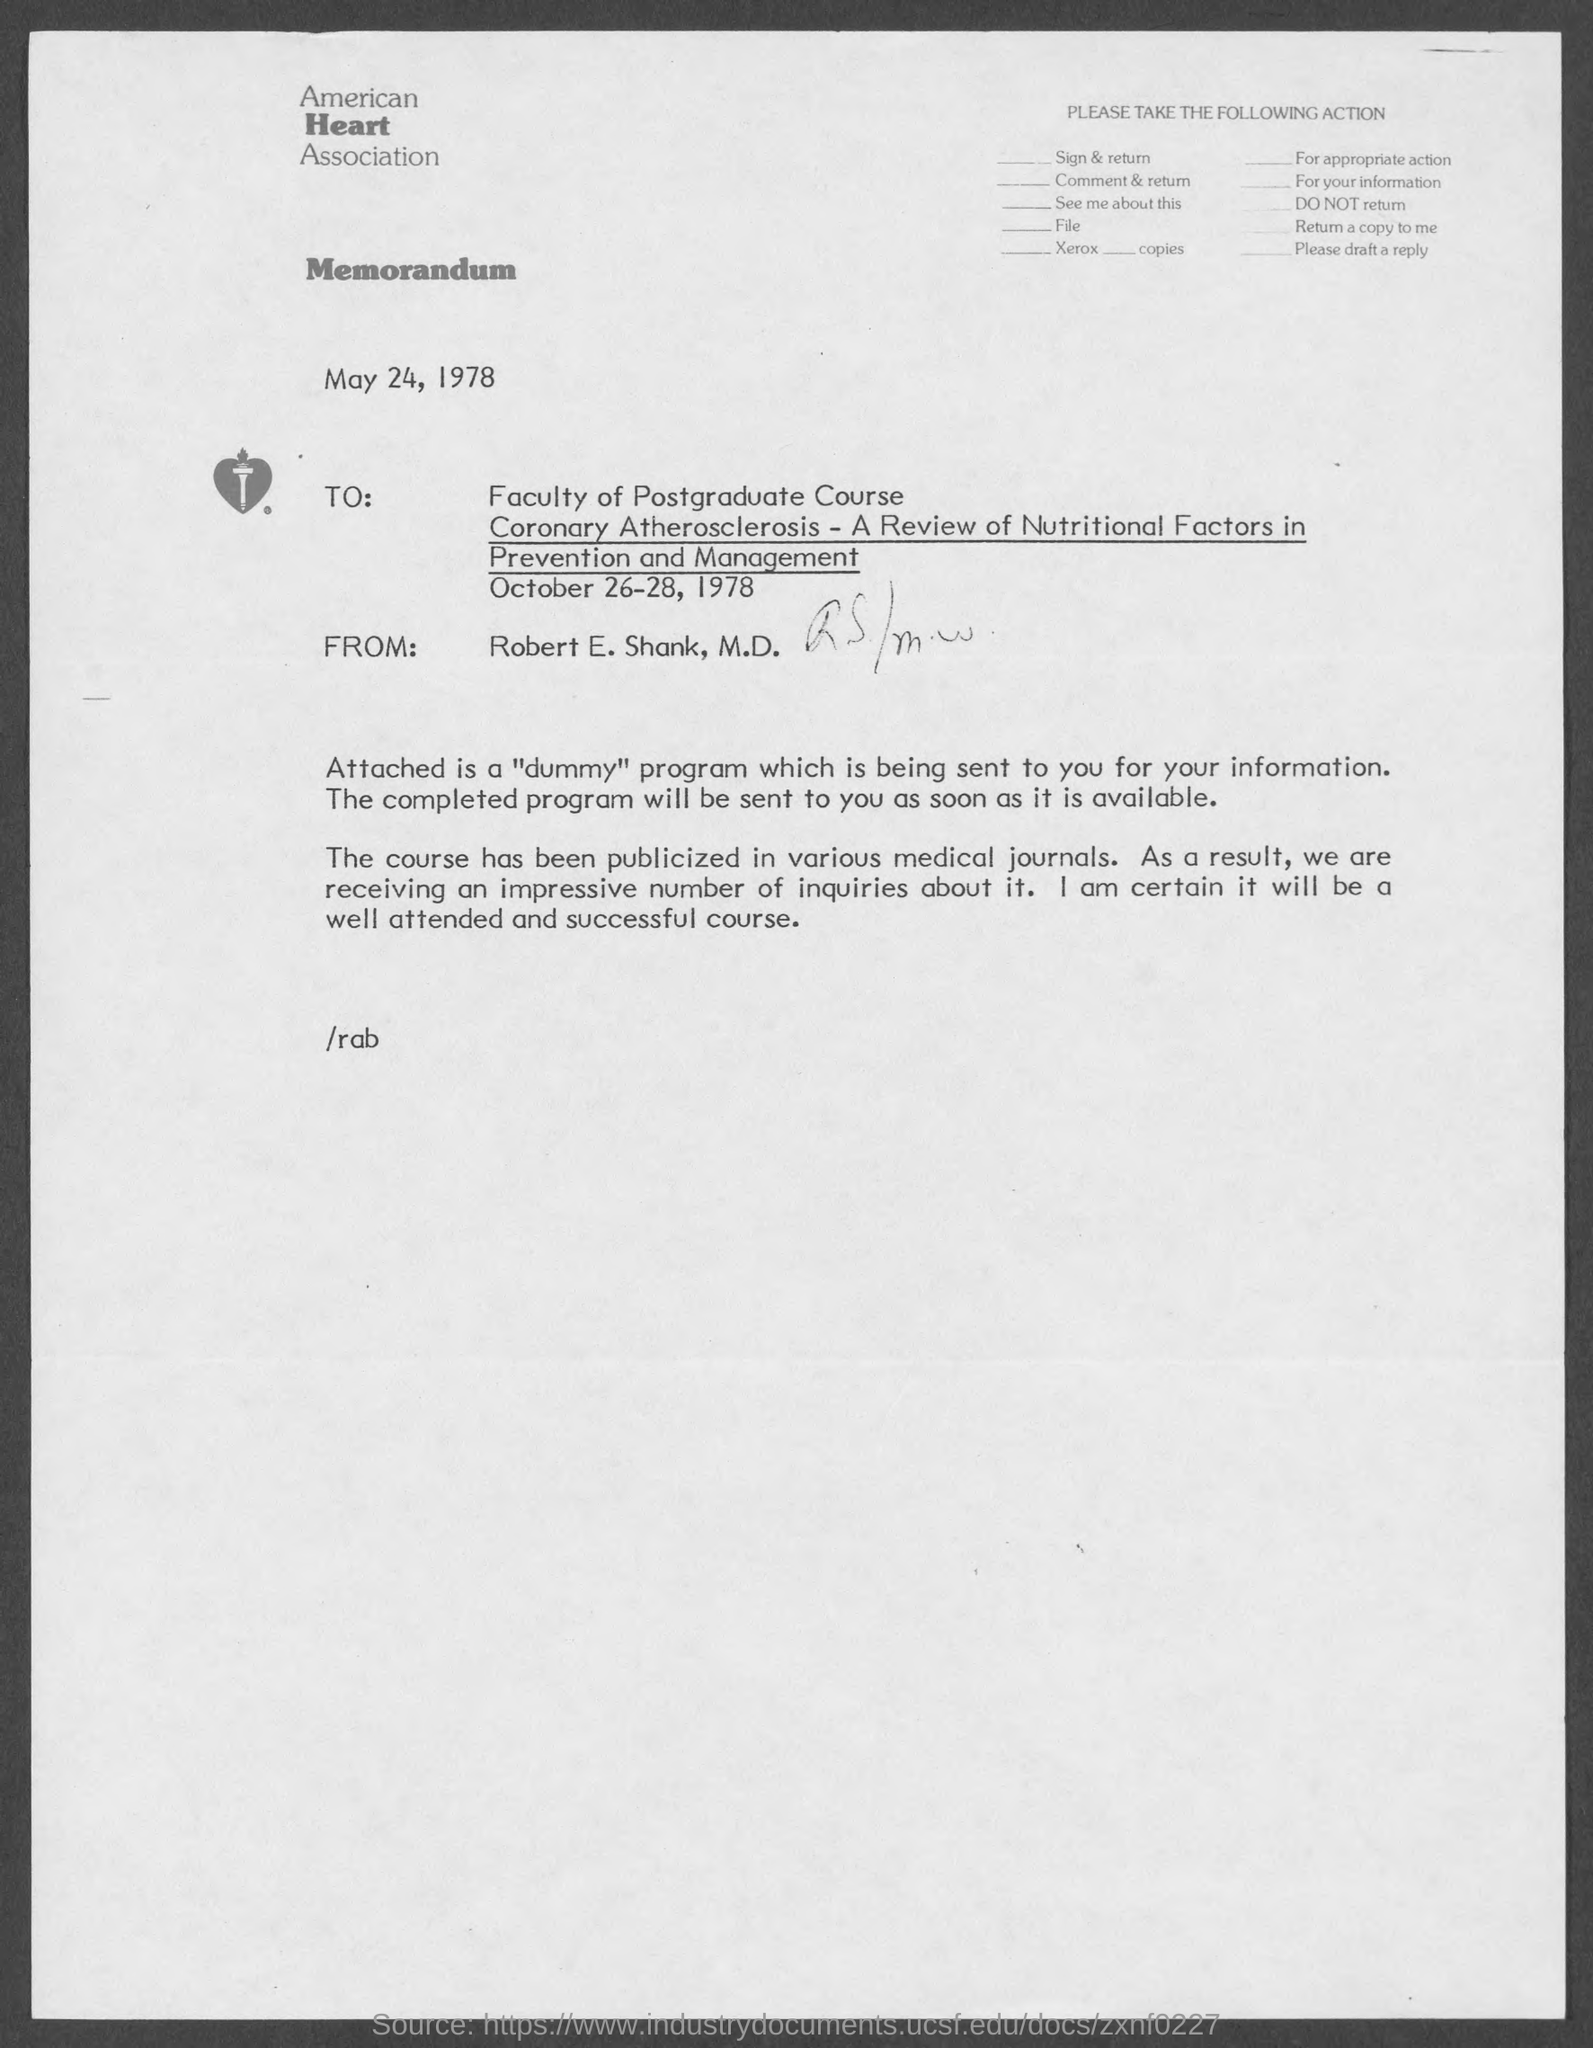Outline some significant characteristics in this image. The from address in a memorandum is "Robert E. Shank, M.D.". The memorandum is dated May 24, 1978. The American Heart Association is the name of a heart association. 